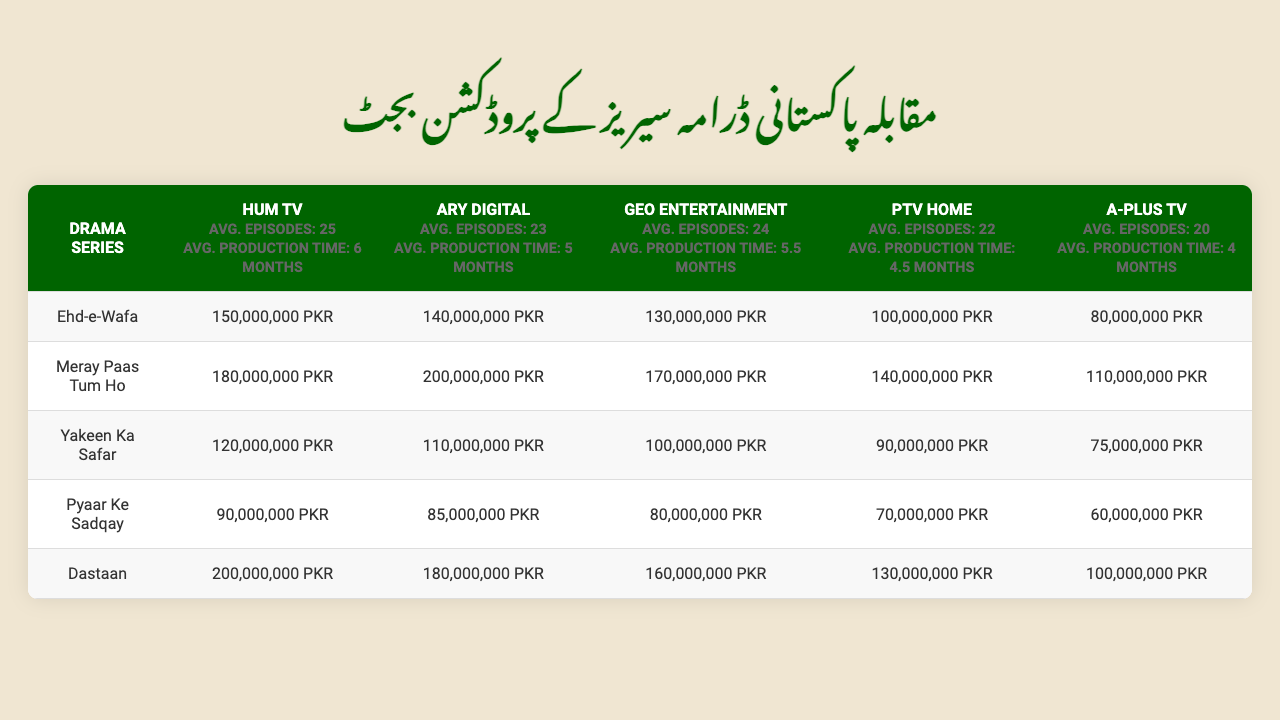What is the highest production budget among the listed drama series? By examining the production budgets for each of the drama series, "Meray Paas Tum Ho" has the highest production budget of 200,000,000 PKR, which can be found under the ARY Digital network.
Answer: 200,000,000 PKR Which network has the lowest average production time? The average production time for each network is listed. A-Plus TV has an average production time of 4 months, which is the lowest compared to the other networks.
Answer: A-Plus TV What is the total production budget of "Dastaan" across all networks? To find the total production budget of "Dastaan," we need to sum the budgets across all networks: 200,000,000 + 180,000,000 + 160,000,000 + 130,000,000 + 100,000,000 = 770,000,000 PKR.
Answer: 770,000,000 PKR Is "Pyaar Ke Sadqay" more expensive to produce on Hum TV than on PTV Home? The production budget for "Pyaar Ke Sadqay" on Hum TV is 90,000,000 PKR, while it is 70,000,000 PKR on PTV Home. Therefore, it is more expensive to produce on Hum TV.
Answer: Yes Which drama from ARY Digital has the lowest production budget? The production budgets for ARY Digital's dramas are listed, and the lowest is for "Pyaar Ke Sadqay" with a budget of 85,000,000 PKR.
Answer: 85,000,000 PKR What is the average production budget of Hum TV dramas? The production budgets for Hum TV dramas are 150,000,000, 180,000,000, 120,000,000, 90,000,000, and 200,000,000 PKR. Summing these gives 840,000,000 PKR. Dividing by the number of dramas (5), the average is 168,000,000 PKR.
Answer: 168,000,000 PKR Which drama series has the same budget in both Hum TV and Geo Entertainment? By comparing the budgets, "Yakeen Ka Safar" has the same budget of 120,000,000 PKR in both Hum TV and Geo Entertainment.
Answer: Yakeen Ka Safar What is the difference in production budget for "Ehd-e-Wafa" between ARY Digital and A-Plus TV? The budget for "Ehd-e-Wafa" is 140,000,000 PKR on ARY Digital and 80,000,000 PKR on A-Plus TV. The difference is 140,000,000 - 80,000,000 = 60,000,000 PKR.
Answer: 60,000,000 PKR Which network has the highest average production cost per episode? To find the average cost per episode for each network, we divide the total budget of each drama by the average episode count for that network. Hum TV's average production cost is highest at 6,720,000 PKR per episode.
Answer: Hum TV How many dramas produced by Geo Entertainment have a budget higher than 150,000,000 PKR? The budgets for Geo Entertainment's dramas are compared, and only "Meray Paas Tum Ho" (170,000,000 PKR) and "Dastaan" (160,000,000 PKR) have budgets higher than 150,000,000 PKR. Therefore, there are 2 dramas.
Answer: 2 